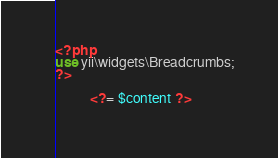<code> <loc_0><loc_0><loc_500><loc_500><_PHP_><?php
use yii\widgets\Breadcrumbs;
?>

          <?= $content ?>
         </code> 